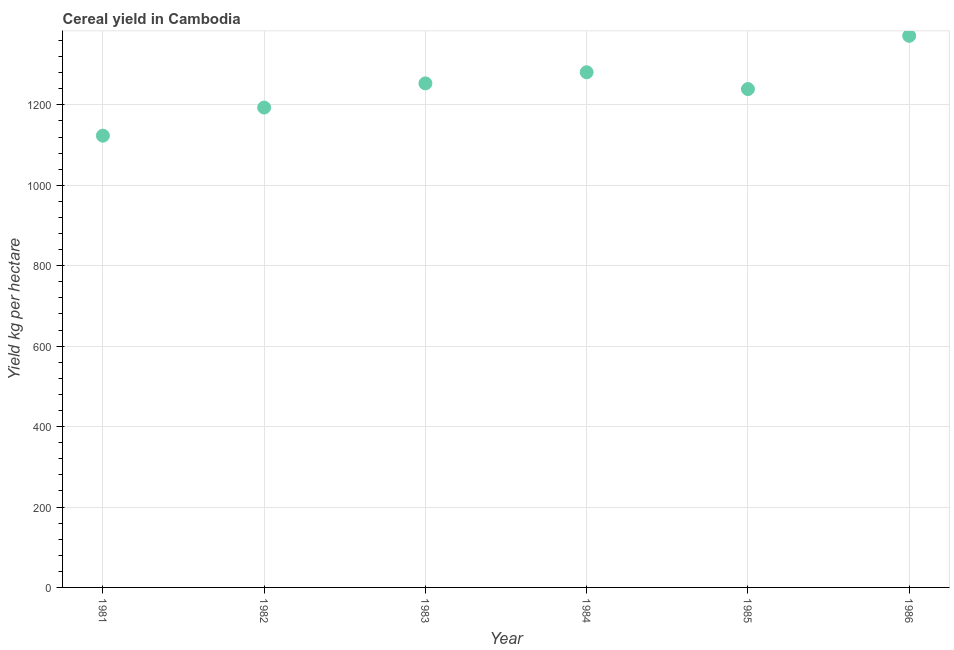What is the cereal yield in 1981?
Make the answer very short. 1123.39. Across all years, what is the maximum cereal yield?
Ensure brevity in your answer.  1371.72. Across all years, what is the minimum cereal yield?
Ensure brevity in your answer.  1123.39. In which year was the cereal yield maximum?
Provide a short and direct response. 1986. What is the sum of the cereal yield?
Give a very brief answer. 7462.3. What is the difference between the cereal yield in 1981 and 1986?
Provide a short and direct response. -248.33. What is the average cereal yield per year?
Ensure brevity in your answer.  1243.72. What is the median cereal yield?
Offer a terse response. 1246.38. In how many years, is the cereal yield greater than 120 kg per hectare?
Keep it short and to the point. 6. What is the ratio of the cereal yield in 1982 to that in 1984?
Provide a short and direct response. 0.93. Is the difference between the cereal yield in 1983 and 1984 greater than the difference between any two years?
Offer a very short reply. No. What is the difference between the highest and the second highest cereal yield?
Your response must be concise. 90.62. What is the difference between the highest and the lowest cereal yield?
Make the answer very short. 248.33. How many dotlines are there?
Provide a succinct answer. 1. How many years are there in the graph?
Ensure brevity in your answer.  6. Are the values on the major ticks of Y-axis written in scientific E-notation?
Make the answer very short. No. Does the graph contain grids?
Ensure brevity in your answer.  Yes. What is the title of the graph?
Ensure brevity in your answer.  Cereal yield in Cambodia. What is the label or title of the Y-axis?
Your answer should be compact. Yield kg per hectare. What is the Yield kg per hectare in 1981?
Ensure brevity in your answer.  1123.39. What is the Yield kg per hectare in 1982?
Ensure brevity in your answer.  1193.32. What is the Yield kg per hectare in 1983?
Provide a succinct answer. 1253.46. What is the Yield kg per hectare in 1984?
Offer a very short reply. 1281.1. What is the Yield kg per hectare in 1985?
Ensure brevity in your answer.  1239.31. What is the Yield kg per hectare in 1986?
Your response must be concise. 1371.72. What is the difference between the Yield kg per hectare in 1981 and 1982?
Make the answer very short. -69.92. What is the difference between the Yield kg per hectare in 1981 and 1983?
Your answer should be very brief. -130.07. What is the difference between the Yield kg per hectare in 1981 and 1984?
Your answer should be compact. -157.7. What is the difference between the Yield kg per hectare in 1981 and 1985?
Give a very brief answer. -115.91. What is the difference between the Yield kg per hectare in 1981 and 1986?
Provide a succinct answer. -248.33. What is the difference between the Yield kg per hectare in 1982 and 1983?
Provide a succinct answer. -60.15. What is the difference between the Yield kg per hectare in 1982 and 1984?
Your answer should be very brief. -87.78. What is the difference between the Yield kg per hectare in 1982 and 1985?
Offer a very short reply. -45.99. What is the difference between the Yield kg per hectare in 1982 and 1986?
Offer a very short reply. -178.4. What is the difference between the Yield kg per hectare in 1983 and 1984?
Your response must be concise. -27.64. What is the difference between the Yield kg per hectare in 1983 and 1985?
Offer a very short reply. 14.16. What is the difference between the Yield kg per hectare in 1983 and 1986?
Provide a short and direct response. -118.26. What is the difference between the Yield kg per hectare in 1984 and 1985?
Provide a succinct answer. 41.79. What is the difference between the Yield kg per hectare in 1984 and 1986?
Make the answer very short. -90.62. What is the difference between the Yield kg per hectare in 1985 and 1986?
Offer a terse response. -132.42. What is the ratio of the Yield kg per hectare in 1981 to that in 1982?
Your answer should be compact. 0.94. What is the ratio of the Yield kg per hectare in 1981 to that in 1983?
Offer a terse response. 0.9. What is the ratio of the Yield kg per hectare in 1981 to that in 1984?
Your answer should be compact. 0.88. What is the ratio of the Yield kg per hectare in 1981 to that in 1985?
Keep it short and to the point. 0.91. What is the ratio of the Yield kg per hectare in 1981 to that in 1986?
Your response must be concise. 0.82. What is the ratio of the Yield kg per hectare in 1982 to that in 1986?
Offer a very short reply. 0.87. What is the ratio of the Yield kg per hectare in 1983 to that in 1986?
Offer a terse response. 0.91. What is the ratio of the Yield kg per hectare in 1984 to that in 1985?
Your answer should be compact. 1.03. What is the ratio of the Yield kg per hectare in 1984 to that in 1986?
Offer a very short reply. 0.93. What is the ratio of the Yield kg per hectare in 1985 to that in 1986?
Ensure brevity in your answer.  0.9. 